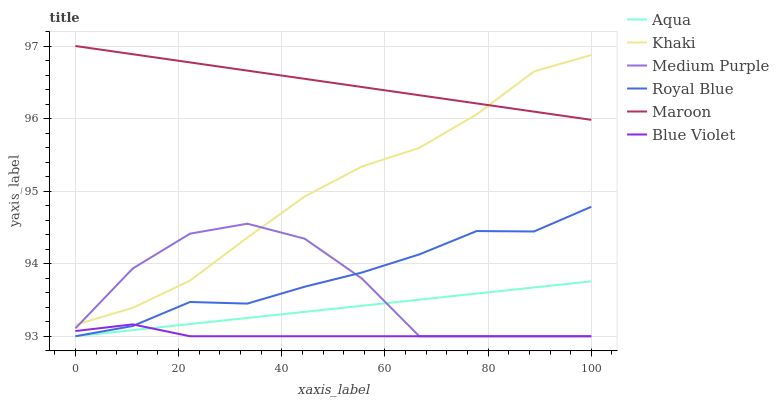Does Blue Violet have the minimum area under the curve?
Answer yes or no. Yes. Does Maroon have the maximum area under the curve?
Answer yes or no. Yes. Does Aqua have the minimum area under the curve?
Answer yes or no. No. Does Aqua have the maximum area under the curve?
Answer yes or no. No. Is Maroon the smoothest?
Answer yes or no. Yes. Is Medium Purple the roughest?
Answer yes or no. Yes. Is Aqua the smoothest?
Answer yes or no. No. Is Aqua the roughest?
Answer yes or no. No. Does Aqua have the lowest value?
Answer yes or no. Yes. Does Maroon have the lowest value?
Answer yes or no. No. Does Maroon have the highest value?
Answer yes or no. Yes. Does Aqua have the highest value?
Answer yes or no. No. Is Aqua less than Maroon?
Answer yes or no. Yes. Is Maroon greater than Aqua?
Answer yes or no. Yes. Does Royal Blue intersect Aqua?
Answer yes or no. Yes. Is Royal Blue less than Aqua?
Answer yes or no. No. Is Royal Blue greater than Aqua?
Answer yes or no. No. Does Aqua intersect Maroon?
Answer yes or no. No. 